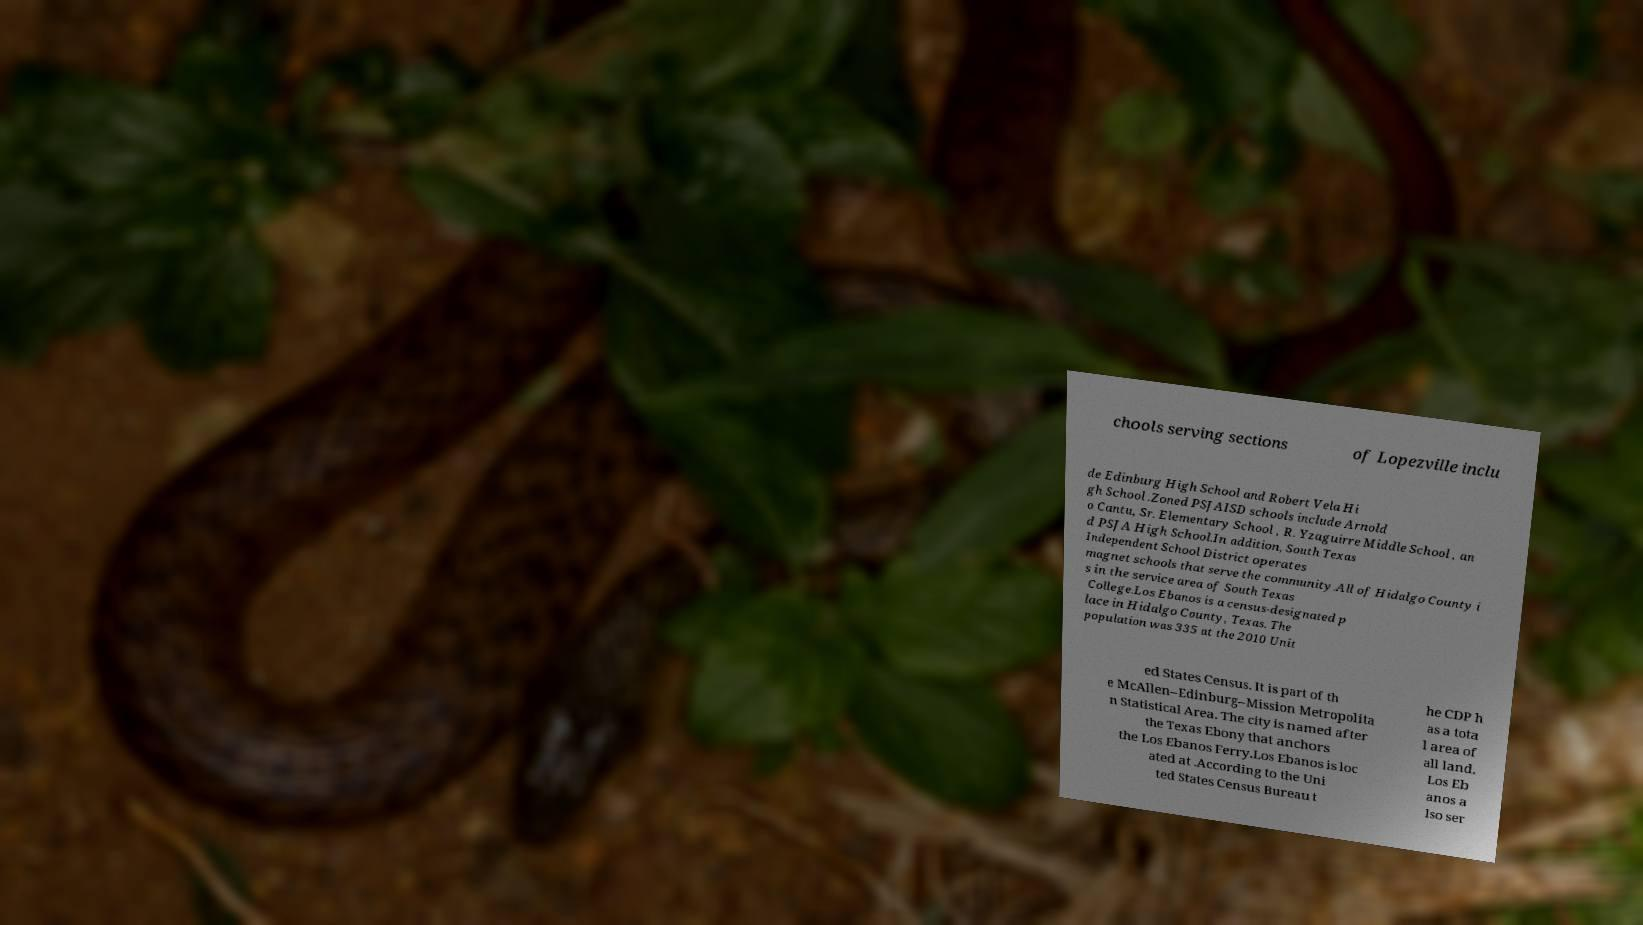Please read and relay the text visible in this image. What does it say? chools serving sections of Lopezville inclu de Edinburg High School and Robert Vela Hi gh School .Zoned PSJAISD schools include Arnold o Cantu, Sr. Elementary School , R. Yzaguirre Middle School , an d PSJA High School.In addition, South Texas Independent School District operates magnet schools that serve the community.All of Hidalgo County i s in the service area of South Texas College.Los Ebanos is a census-designated p lace in Hidalgo County, Texas. The population was 335 at the 2010 Unit ed States Census. It is part of th e McAllen–Edinburg–Mission Metropolita n Statistical Area. The city is named after the Texas Ebony that anchors the Los Ebanos Ferry.Los Ebanos is loc ated at .According to the Uni ted States Census Bureau t he CDP h as a tota l area of all land. Los Eb anos a lso ser 